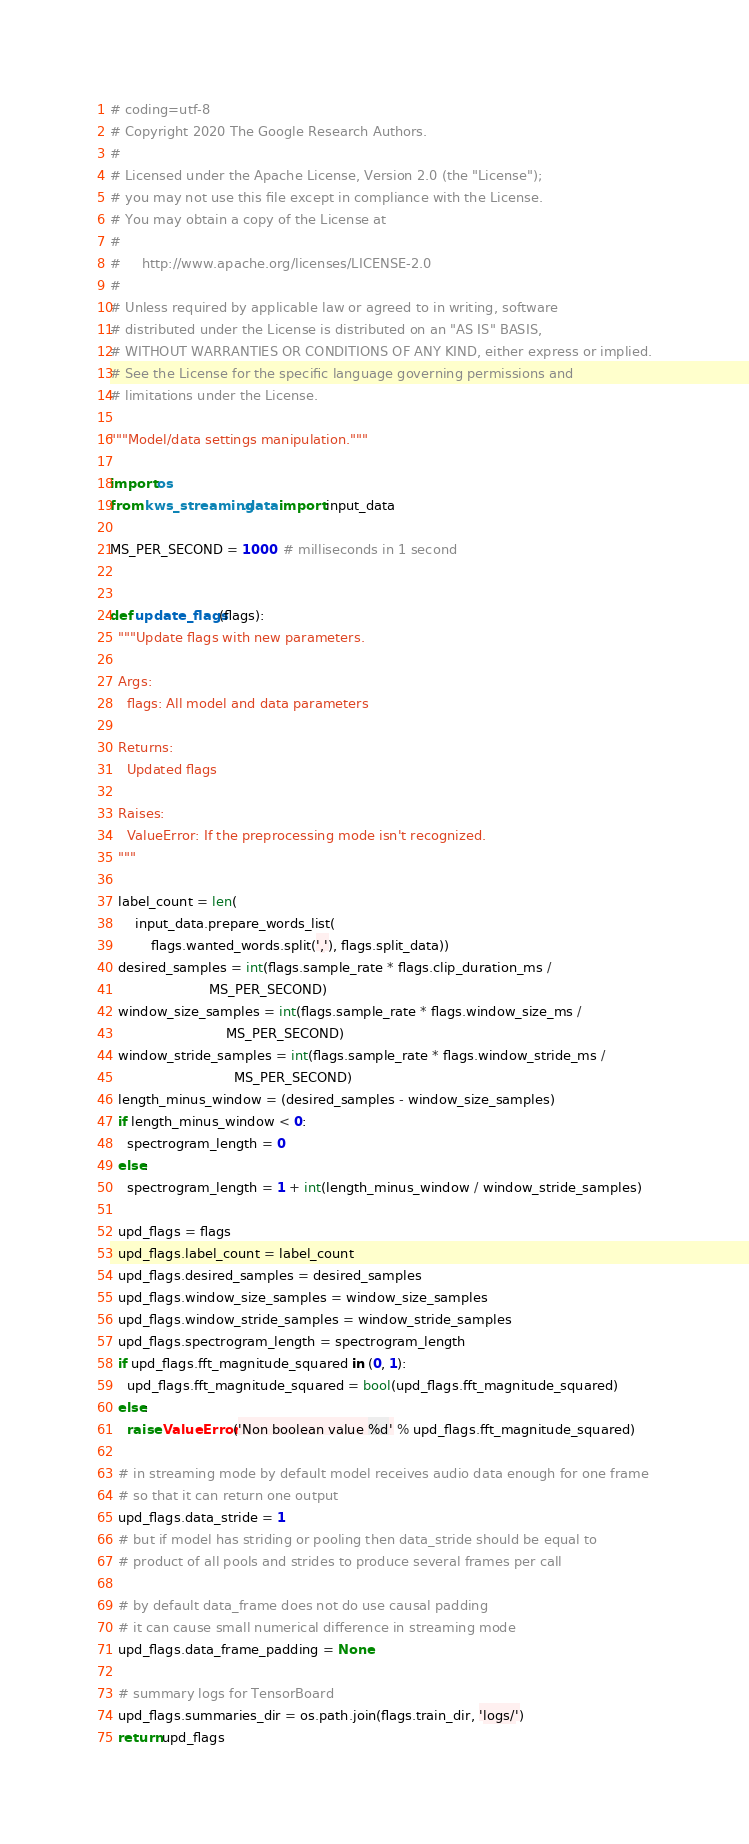<code> <loc_0><loc_0><loc_500><loc_500><_Python_># coding=utf-8
# Copyright 2020 The Google Research Authors.
#
# Licensed under the Apache License, Version 2.0 (the "License");
# you may not use this file except in compliance with the License.
# You may obtain a copy of the License at
#
#     http://www.apache.org/licenses/LICENSE-2.0
#
# Unless required by applicable law or agreed to in writing, software
# distributed under the License is distributed on an "AS IS" BASIS,
# WITHOUT WARRANTIES OR CONDITIONS OF ANY KIND, either express or implied.
# See the License for the specific language governing permissions and
# limitations under the License.

"""Model/data settings manipulation."""

import os
from kws_streaming.data import input_data

MS_PER_SECOND = 1000  # milliseconds in 1 second


def update_flags(flags):
  """Update flags with new parameters.

  Args:
    flags: All model and data parameters

  Returns:
    Updated flags

  Raises:
    ValueError: If the preprocessing mode isn't recognized.
  """

  label_count = len(
      input_data.prepare_words_list(
          flags.wanted_words.split(','), flags.split_data))
  desired_samples = int(flags.sample_rate * flags.clip_duration_ms /
                        MS_PER_SECOND)
  window_size_samples = int(flags.sample_rate * flags.window_size_ms /
                            MS_PER_SECOND)
  window_stride_samples = int(flags.sample_rate * flags.window_stride_ms /
                              MS_PER_SECOND)
  length_minus_window = (desired_samples - window_size_samples)
  if length_minus_window < 0:
    spectrogram_length = 0
  else:
    spectrogram_length = 1 + int(length_minus_window / window_stride_samples)

  upd_flags = flags
  upd_flags.label_count = label_count
  upd_flags.desired_samples = desired_samples
  upd_flags.window_size_samples = window_size_samples
  upd_flags.window_stride_samples = window_stride_samples
  upd_flags.spectrogram_length = spectrogram_length
  if upd_flags.fft_magnitude_squared in (0, 1):
    upd_flags.fft_magnitude_squared = bool(upd_flags.fft_magnitude_squared)
  else:
    raise ValueError('Non boolean value %d' % upd_flags.fft_magnitude_squared)

  # in streaming mode by default model receives audio data enough for one frame
  # so that it can return one output
  upd_flags.data_stride = 1
  # but if model has striding or pooling then data_stride should be equal to
  # product of all pools and strides to produce several frames per call

  # by default data_frame does not do use causal padding
  # it can cause small numerical difference in streaming mode
  upd_flags.data_frame_padding = None

  # summary logs for TensorBoard
  upd_flags.summaries_dir = os.path.join(flags.train_dir, 'logs/')
  return upd_flags
</code> 